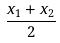<formula> <loc_0><loc_0><loc_500><loc_500>\frac { x _ { 1 } + x _ { 2 } } { 2 }</formula> 